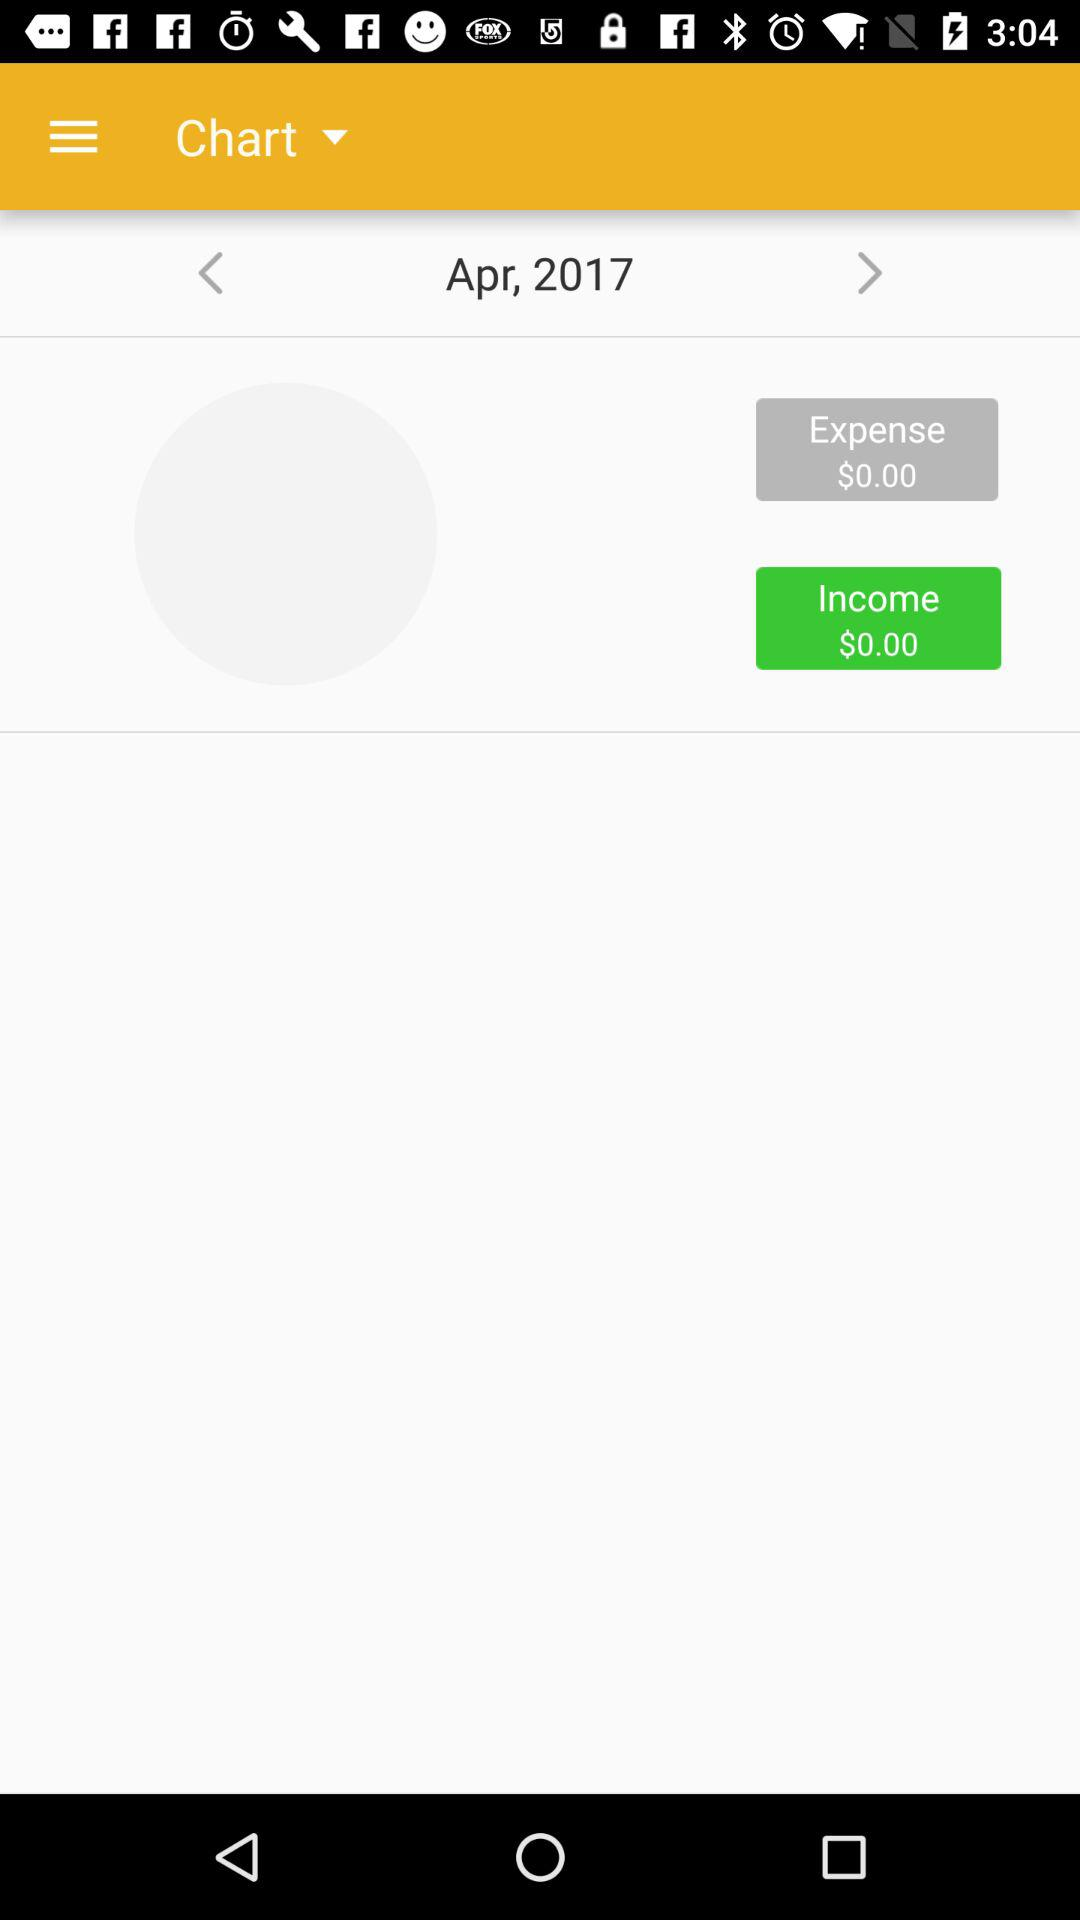What is the currency of the income? The currency of the income is dollars. 